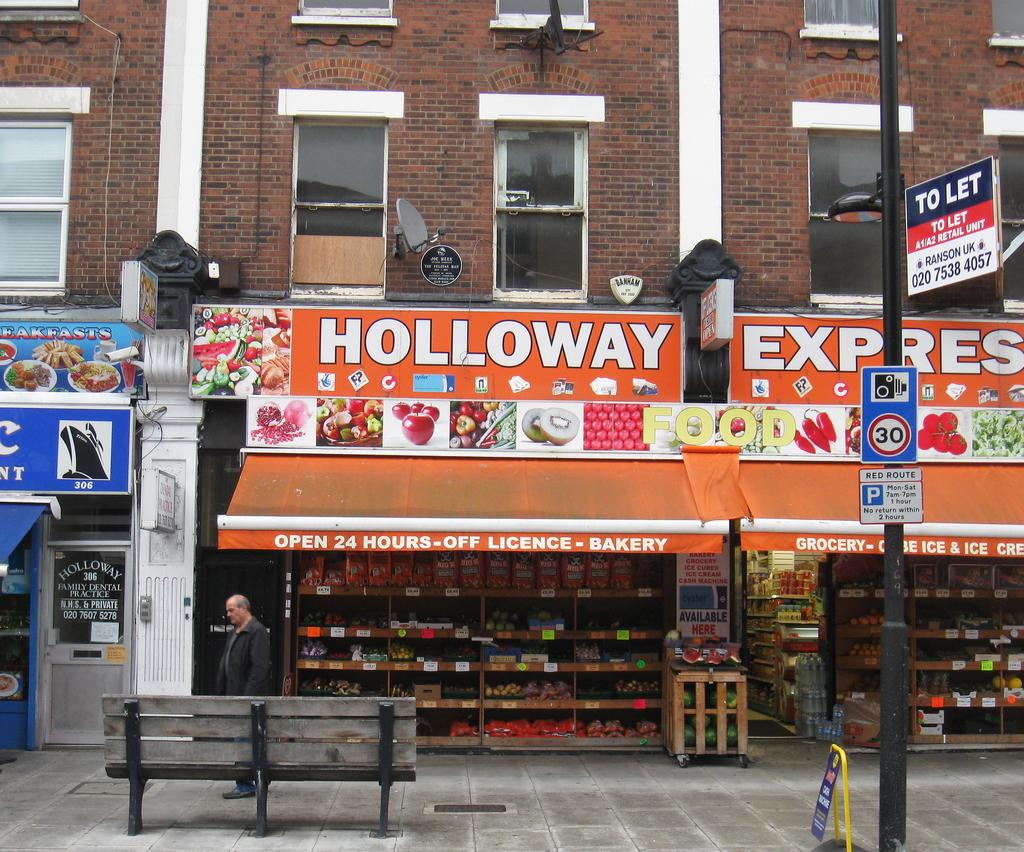What type of objects can be seen in the image? There are boards, a pole, a bench, a man on a path, stores, boards on the stores, a building, windows on the building, and other objects in the image. What is the man on the path doing? The man on the path is not performing any specific action in the image. What is the purpose of the pole in the image? The purpose of the pole in the image is not specified, but it could be for support or signage. How many stores are visible in the image? There are stores visible in the image, but the exact number is not specified. Can you observe the wall being pushed in the image? There is no wall or pushing action depicted in the image. What type of observation can be made about the man's behavior in the image? The man's behavior is not specified in the image, so no observation can be made about it. 